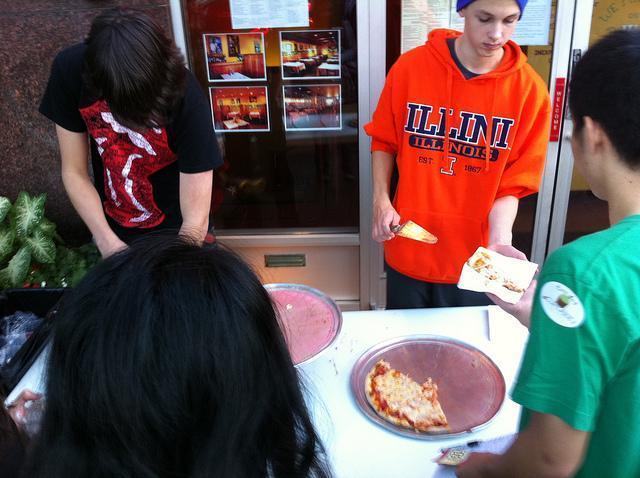How many people are there?
Give a very brief answer. 4. How many dogs are in the photo?
Give a very brief answer. 0. 